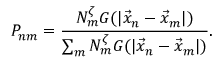Convert formula to latex. <formula><loc_0><loc_0><loc_500><loc_500>P _ { n m } = \frac { N _ { m } ^ { \zeta } G ( | \vec { x } _ { n } - \vec { x } _ { m } | ) } { \sum _ { m } N _ { m } ^ { \zeta } G ( | \vec { x } _ { n } - \vec { x } _ { m } | ) } .</formula> 